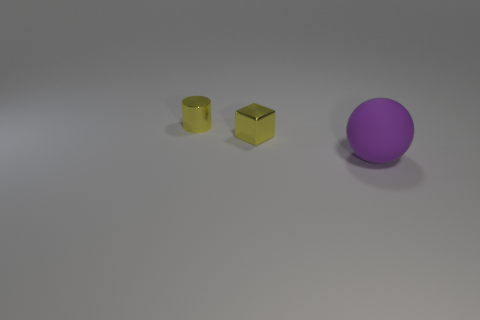Are the yellow cube and the large purple sphere made of the same material?
Your response must be concise. No. The thing that is the same color as the metal block is what shape?
Offer a very short reply. Cylinder. There is a tiny metallic thing that is on the left side of the small metal cube; is it the same color as the block?
Make the answer very short. Yes. How many small yellow objects are in front of the yellow object on the left side of the small cube?
Your answer should be very brief. 1. What is the color of the thing that is the same size as the yellow shiny cube?
Your response must be concise. Yellow. There is a thing behind the small metallic cube; what material is it?
Your answer should be compact. Metal. There is a object that is to the left of the rubber sphere and in front of the yellow shiny cylinder; what material is it made of?
Keep it short and to the point. Metal. Do the yellow thing behind the yellow cube and the big rubber ball have the same size?
Provide a succinct answer. No. What is the shape of the matte thing?
Provide a short and direct response. Sphere. How many objects are both left of the big purple sphere and in front of the small cylinder?
Provide a short and direct response. 1. 